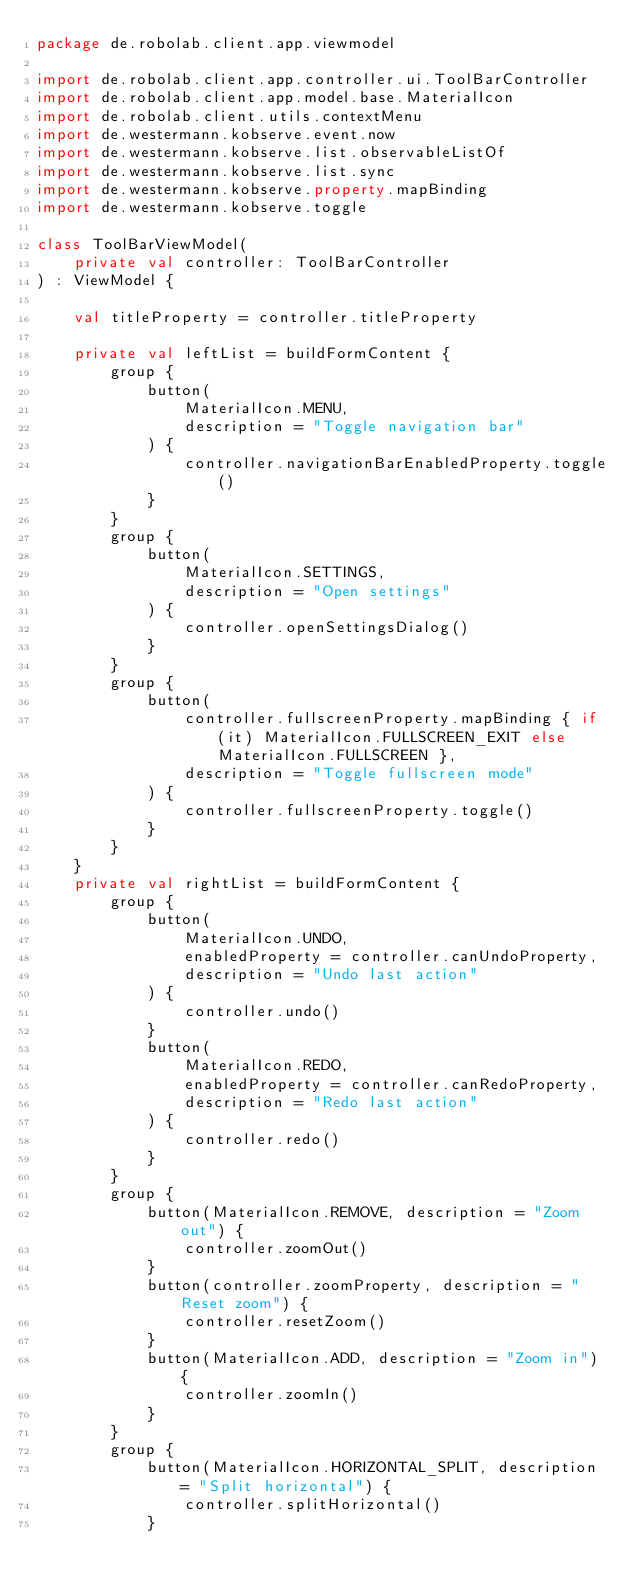Convert code to text. <code><loc_0><loc_0><loc_500><loc_500><_Kotlin_>package de.robolab.client.app.viewmodel

import de.robolab.client.app.controller.ui.ToolBarController
import de.robolab.client.app.model.base.MaterialIcon
import de.robolab.client.utils.contextMenu
import de.westermann.kobserve.event.now
import de.westermann.kobserve.list.observableListOf
import de.westermann.kobserve.list.sync
import de.westermann.kobserve.property.mapBinding
import de.westermann.kobserve.toggle

class ToolBarViewModel(
    private val controller: ToolBarController
) : ViewModel {

    val titleProperty = controller.titleProperty

    private val leftList = buildFormContent {
        group {
            button(
                MaterialIcon.MENU,
                description = "Toggle navigation bar"
            ) {
                controller.navigationBarEnabledProperty.toggle()
            }
        }
        group {
            button(
                MaterialIcon.SETTINGS,
                description = "Open settings"
            ) {
                controller.openSettingsDialog()
            }
        }
        group {
            button(
                controller.fullscreenProperty.mapBinding { if (it) MaterialIcon.FULLSCREEN_EXIT else MaterialIcon.FULLSCREEN },
                description = "Toggle fullscreen mode"
            ) {
                controller.fullscreenProperty.toggle()
            }
        }
    }
    private val rightList = buildFormContent { 
        group {
            button(
                MaterialIcon.UNDO,
                enabledProperty = controller.canUndoProperty,
                description = "Undo last action"
            ) {
                controller.undo()
            }
            button(
                MaterialIcon.REDO,
                enabledProperty = controller.canRedoProperty,
                description = "Redo last action"
            ) {
                controller.redo()
            }
        }
        group {
            button(MaterialIcon.REMOVE, description = "Zoom out") {
                controller.zoomOut()
            }
            button(controller.zoomProperty, description = "Reset zoom") {
                controller.resetZoom()
            }
            button(MaterialIcon.ADD, description = "Zoom in") {
                controller.zoomIn()
            }
        }
        group {
            button(MaterialIcon.HORIZONTAL_SPLIT, description = "Split horizontal") {
                controller.splitHorizontal()
            }</code> 